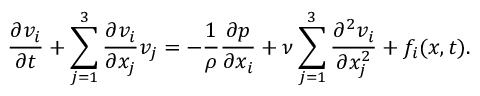<formula> <loc_0><loc_0><loc_500><loc_500>{ \frac { \partial v _ { i } } { \partial t } } + \sum _ { j = 1 } ^ { 3 } { \frac { \partial v _ { i } } { \partial x _ { j } } } v _ { j } = - { \frac { 1 } { \rho } } { \frac { \partial p } { \partial x _ { i } } } + \nu \sum _ { j = 1 } ^ { 3 } { \frac { \partial ^ { 2 } v _ { i } } { \partial x _ { j } ^ { 2 } } } + f _ { i } ( { x } , t ) .</formula> 